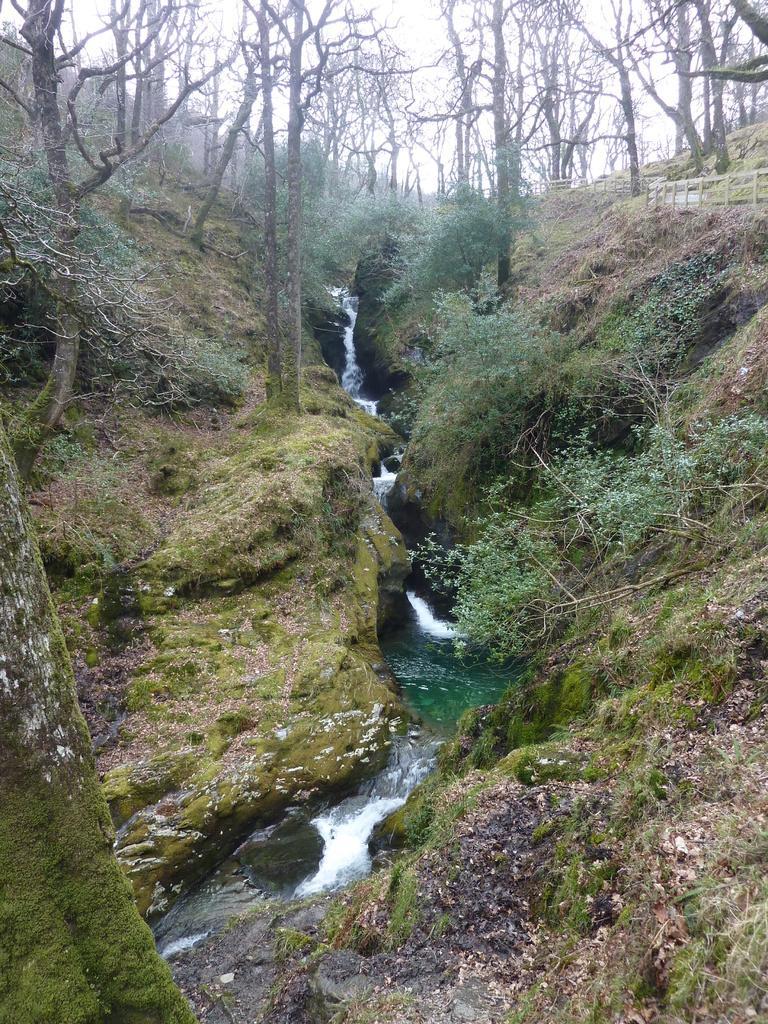Please provide a concise description of this image. This image looks like it is clicked in a forest. On the left and right, there are plants and trees along with green grass on the ground. In the middle, there is water. On the right, we can see a fencing made up of wood. At the top, there is sky. 